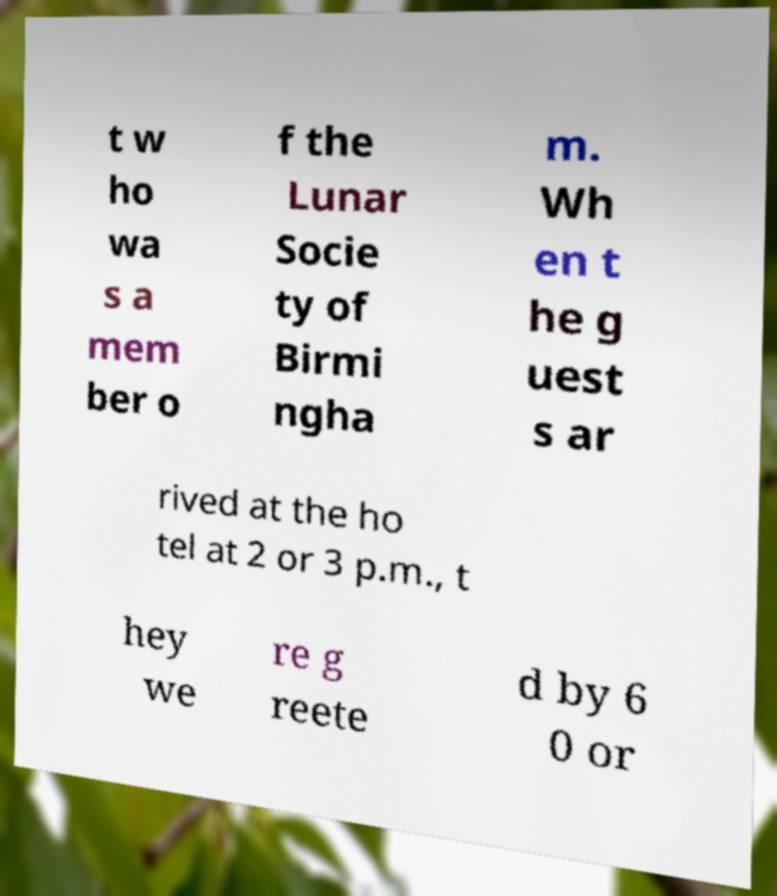Could you extract and type out the text from this image? t w ho wa s a mem ber o f the Lunar Socie ty of Birmi ngha m. Wh en t he g uest s ar rived at the ho tel at 2 or 3 p.m., t hey we re g reete d by 6 0 or 